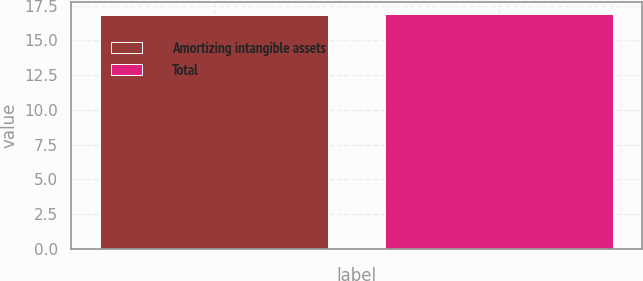Convert chart to OTSL. <chart><loc_0><loc_0><loc_500><loc_500><bar_chart><fcel>Amortizing intangible assets<fcel>Total<nl><fcel>16.8<fcel>16.9<nl></chart> 